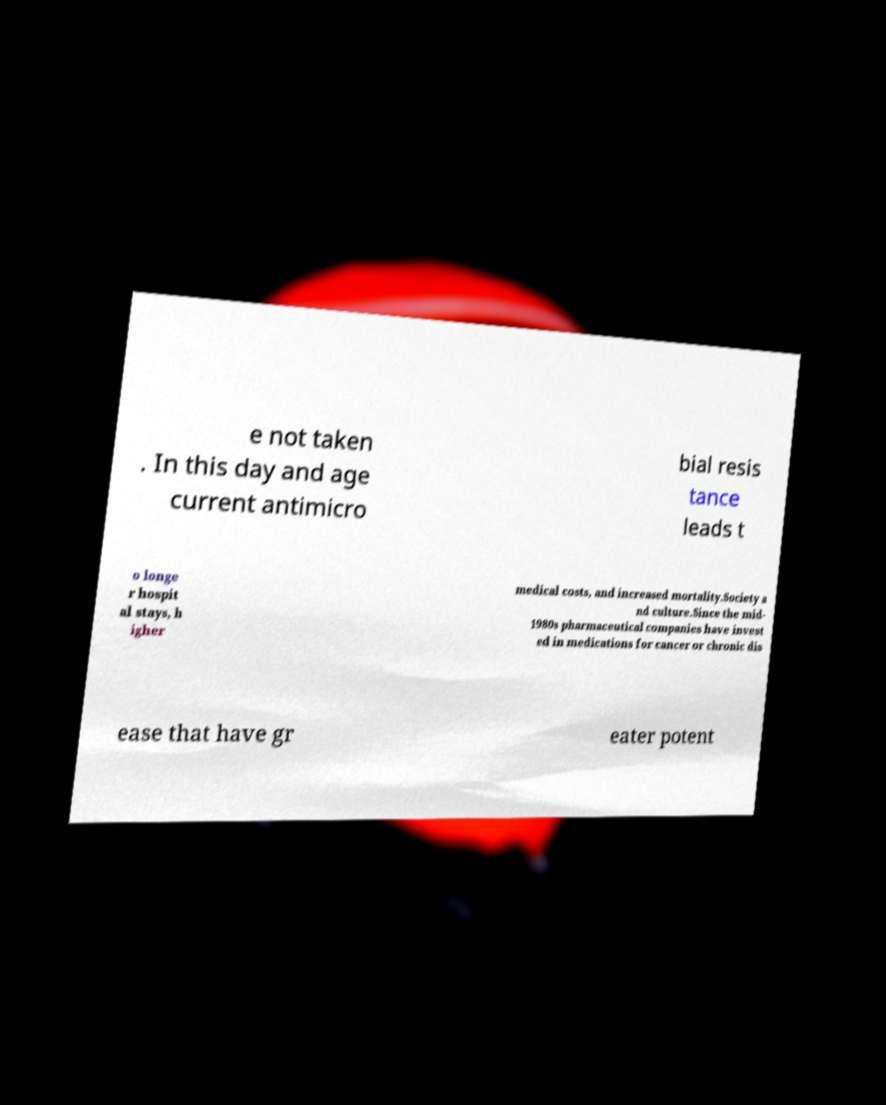I need the written content from this picture converted into text. Can you do that? e not taken . In this day and age current antimicro bial resis tance leads t o longe r hospit al stays, h igher medical costs, and increased mortality.Society a nd culture.Since the mid- 1980s pharmaceutical companies have invest ed in medications for cancer or chronic dis ease that have gr eater potent 